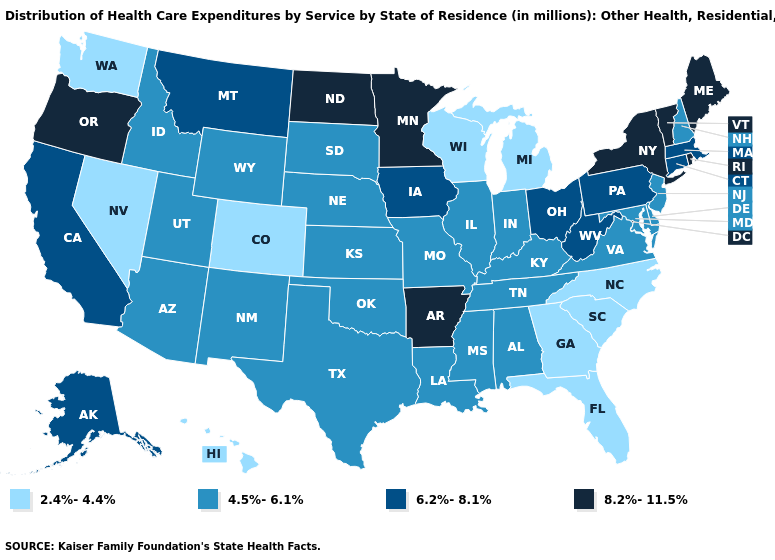Among the states that border Nebraska , does Iowa have the highest value?
Give a very brief answer. Yes. Which states have the highest value in the USA?
Be succinct. Arkansas, Maine, Minnesota, New York, North Dakota, Oregon, Rhode Island, Vermont. Which states hav the highest value in the West?
Give a very brief answer. Oregon. Does West Virginia have the highest value in the South?
Be succinct. No. Is the legend a continuous bar?
Answer briefly. No. Name the states that have a value in the range 2.4%-4.4%?
Give a very brief answer. Colorado, Florida, Georgia, Hawaii, Michigan, Nevada, North Carolina, South Carolina, Washington, Wisconsin. Among the states that border Wisconsin , does Minnesota have the highest value?
Concise answer only. Yes. Name the states that have a value in the range 4.5%-6.1%?
Concise answer only. Alabama, Arizona, Delaware, Idaho, Illinois, Indiana, Kansas, Kentucky, Louisiana, Maryland, Mississippi, Missouri, Nebraska, New Hampshire, New Jersey, New Mexico, Oklahoma, South Dakota, Tennessee, Texas, Utah, Virginia, Wyoming. Does the first symbol in the legend represent the smallest category?
Write a very short answer. Yes. What is the highest value in the USA?
Quick response, please. 8.2%-11.5%. Name the states that have a value in the range 8.2%-11.5%?
Concise answer only. Arkansas, Maine, Minnesota, New York, North Dakota, Oregon, Rhode Island, Vermont. What is the highest value in the USA?
Answer briefly. 8.2%-11.5%. Does Iowa have the lowest value in the USA?
Write a very short answer. No. Does Arkansas have the highest value in the South?
Short answer required. Yes. What is the value of Kansas?
Be succinct. 4.5%-6.1%. 